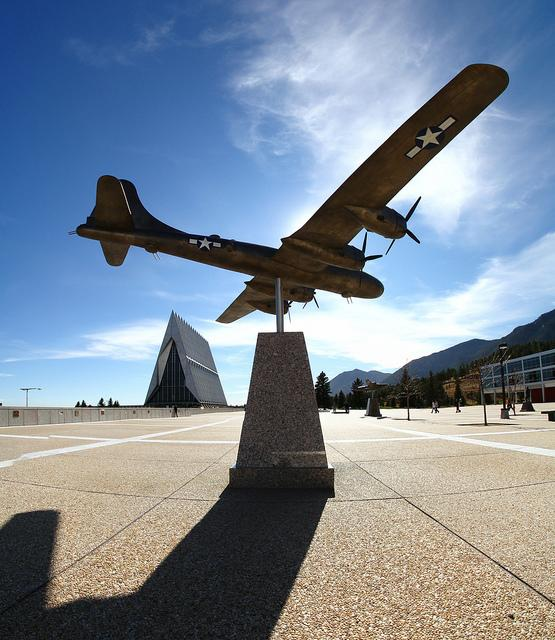How fast is this plane flying now? Please explain your reasoning. zero mph. The plane is not flying, it is on display. 